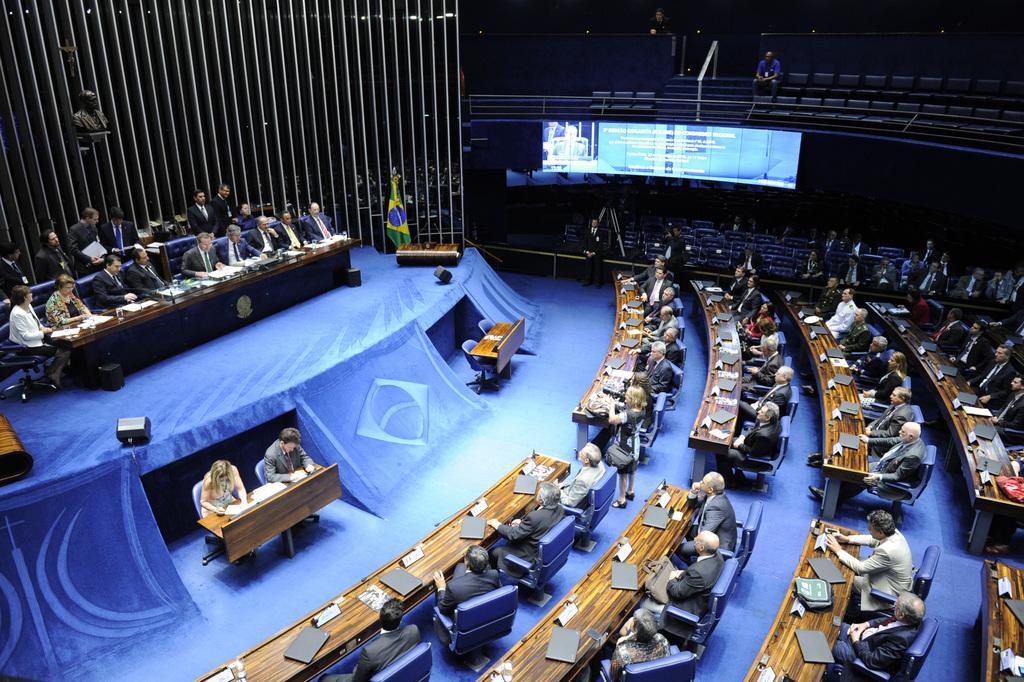Describe this image in one or two sentences. In this image there is a conference hall, in that hall there are people sitting on chairs, in front of them there are tables, on that tables there are laptops and papers, in the background there is a sculpture and iron roads and chairs, few people are sitting on chairs and there is a screen. 